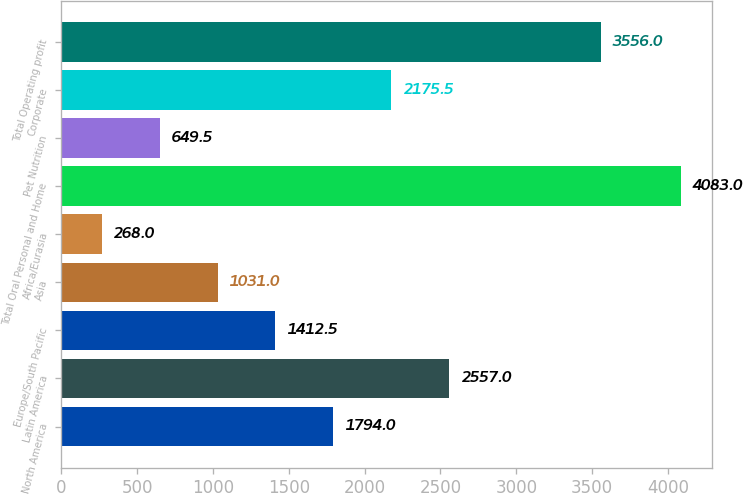Convert chart to OTSL. <chart><loc_0><loc_0><loc_500><loc_500><bar_chart><fcel>North America<fcel>Latin America<fcel>Europe/South Pacific<fcel>Asia<fcel>Africa/Eurasia<fcel>Total Oral Personal and Home<fcel>Pet Nutrition<fcel>Corporate<fcel>Total Operating profit<nl><fcel>1794<fcel>2557<fcel>1412.5<fcel>1031<fcel>268<fcel>4083<fcel>649.5<fcel>2175.5<fcel>3556<nl></chart> 